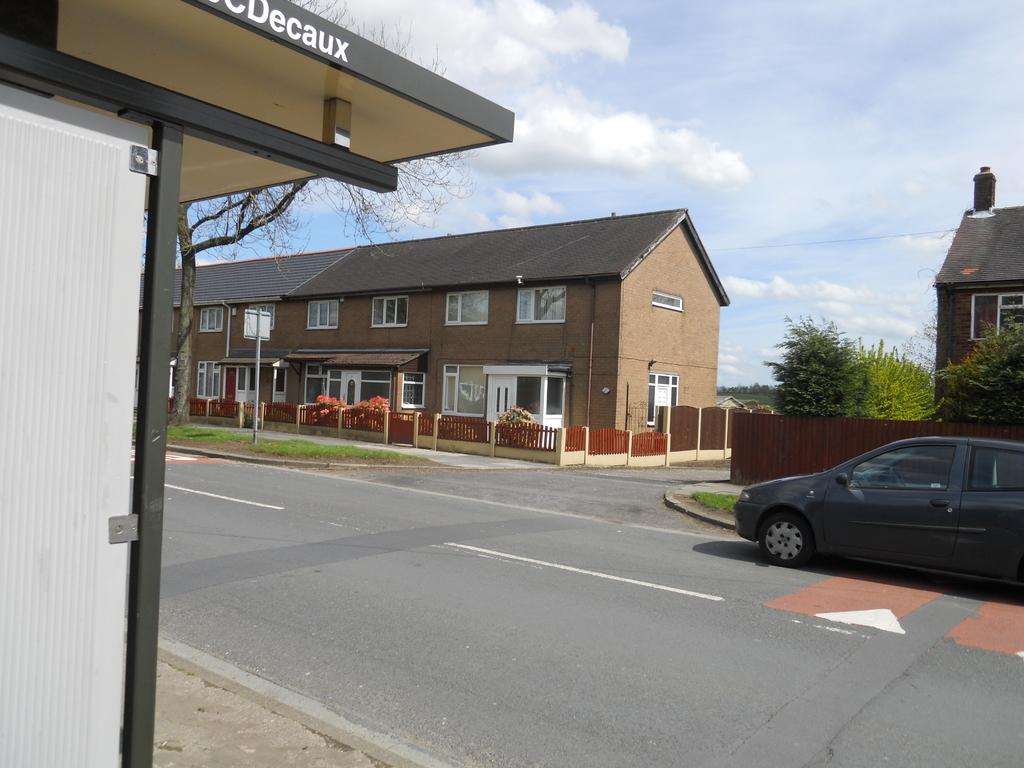What type of structures can be seen in the image? There are buildings in the image. What is the purpose of the fence in the image? The purpose of the fence in the image is not specified, but it could be for enclosing an area or providing a boundary. What type of vegetation is present in the image? There are trees in the image. What is the tall, thin object in the image? There is a pole in the image. What is moving along the road in the image? There is a vehicle on the road in the image. What can be seen in the background of the image? The sky is visible in the background of the image. What is the manager's income in the image? There is no information about a manager or their income in the image. How many visitors are present in the image? There is no mention of visitors in the image. 